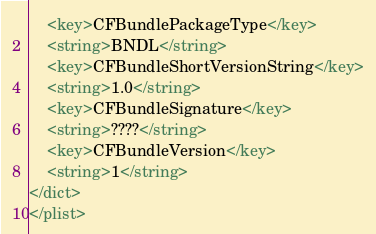Convert code to text. <code><loc_0><loc_0><loc_500><loc_500><_XML_>	<key>CFBundlePackageType</key>
	<string>BNDL</string>
	<key>CFBundleShortVersionString</key>
	<string>1.0</string>
	<key>CFBundleSignature</key>
	<string>????</string>
	<key>CFBundleVersion</key>
	<string>1</string>
</dict>
</plist>
</code> 